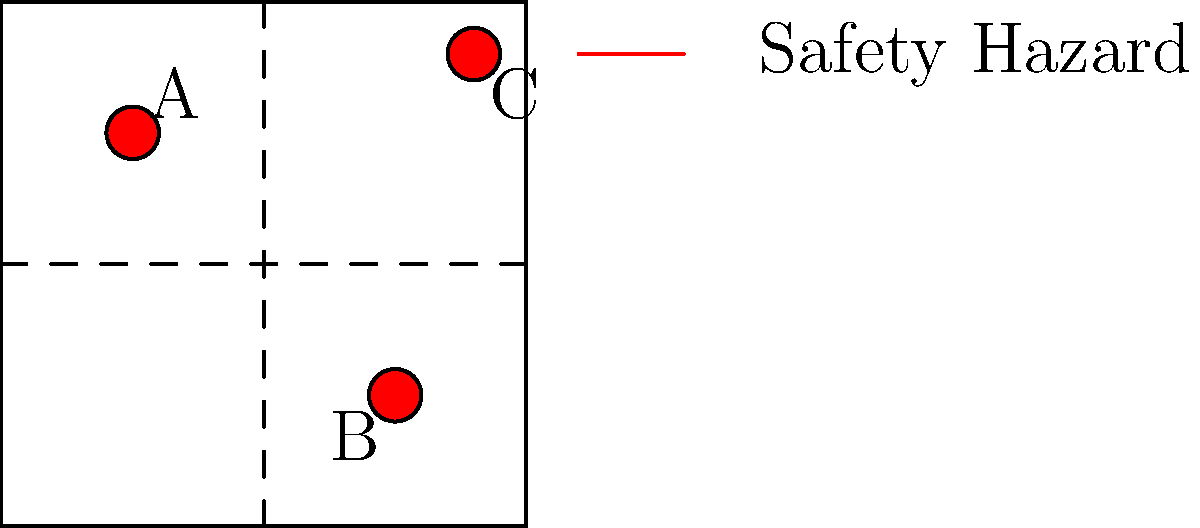In the annotated toy schematic above, computer vision has identified three potential safety hazards labeled A, B, and C. Which of these hazards is most likely to be a choking risk for young children, and how could machine learning be leveraged to improve the identification and classification of such hazards in toy designs? To answer this question, we need to consider the following steps:

1. Analyze the schematic:
   The diagram shows a toy design with three identified safety hazards (A, B, and C) marked by red circles.

2. Identify potential choking hazards:
   Among the three marked areas, B is located in the lower part of the toy and appears to be smaller than the others. This suggests it could represent a small, detachable part, which is a common choking hazard for young children.

3. Understanding choking hazards:
   Choking hazards are typically small parts that can fit into a child's mouth and potentially block their airway. The U.S. Consumer Product Safety Commission (CPSC) defines a choking hazard as any object that fits entirely into a specially designed test cylinder with a diameter of 1.25 inches and a depth of 2.25 inches.

4. Machine learning application:
   Machine learning can improve the identification and classification of safety hazards in toy designs through:

   a) Object detection: Train models to recognize small parts, sharp edges, and other potential hazards in toy schematics or 3D models.
   
   b) Size estimation: Implement algorithms to estimate the size of toy components relative to standard safety measurements (e.g., the CPSC test cylinder).
   
   c) Material classification: Develop models to identify materials that could pose risks (e.g., toxic materials, easily breakable parts).
   
   d) Historical data analysis: Use past recall data and safety reports to train models to recognize patterns in unsafe designs.
   
   e) Automated risk assessment: Create a system that combines multiple factors (size, material, location) to provide an overall safety score for each identified potential hazard.

5. Continuous improvement:
   As new toy designs are created and safety standards evolve, the machine learning models can be continuously updated and refined to improve accuracy and adapt to new types of hazards.
Answer: B; ML can enhance hazard detection through object detection, size estimation, material classification, historical data analysis, and automated risk assessment. 